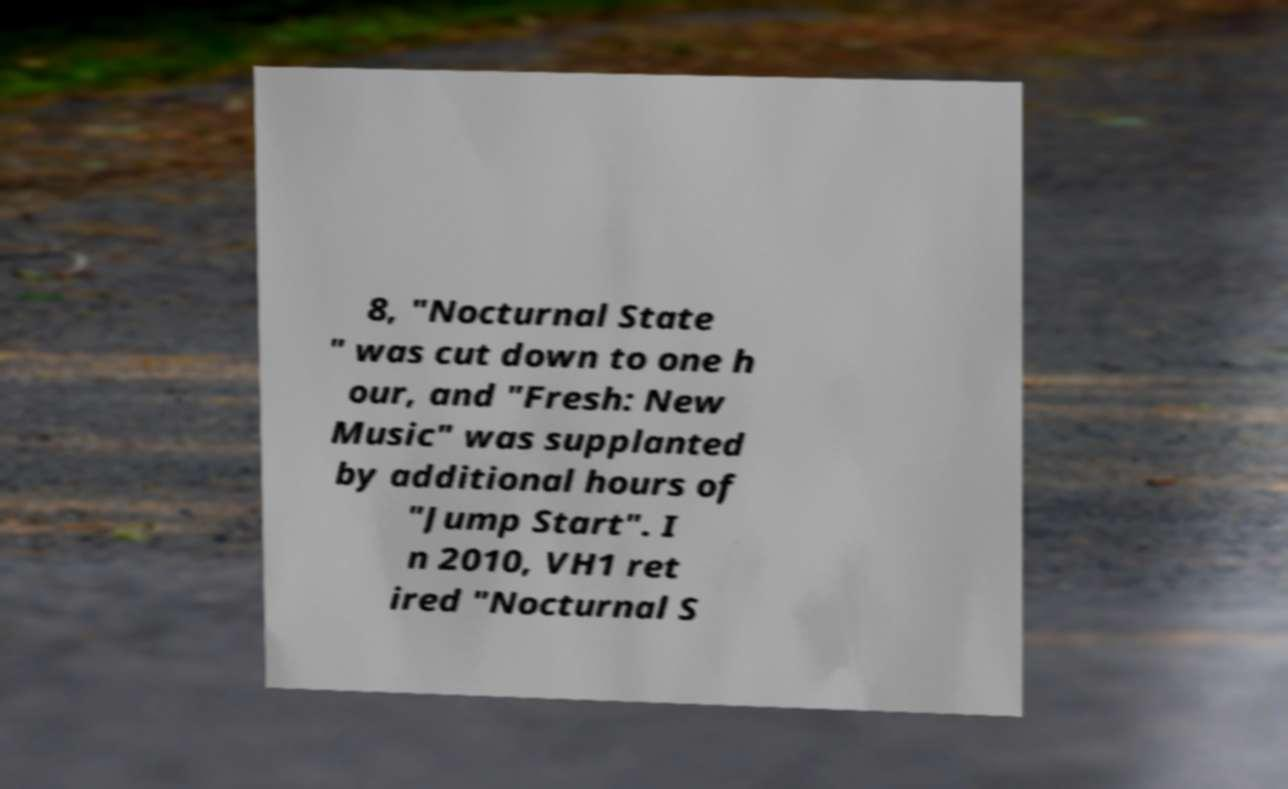There's text embedded in this image that I need extracted. Can you transcribe it verbatim? 8, "Nocturnal State " was cut down to one h our, and "Fresh: New Music" was supplanted by additional hours of "Jump Start". I n 2010, VH1 ret ired "Nocturnal S 